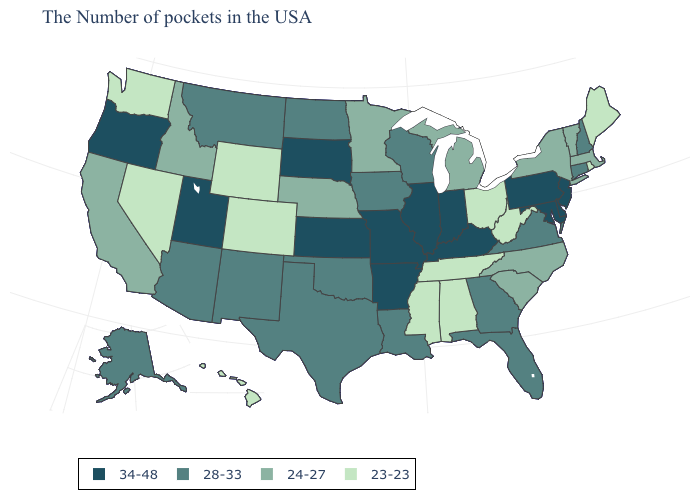What is the value of New Mexico?
Short answer required. 28-33. What is the value of Vermont?
Answer briefly. 24-27. Does South Dakota have the highest value in the USA?
Short answer required. Yes. Name the states that have a value in the range 34-48?
Concise answer only. New Jersey, Delaware, Maryland, Pennsylvania, Kentucky, Indiana, Illinois, Missouri, Arkansas, Kansas, South Dakota, Utah, Oregon. What is the value of New Hampshire?
Keep it brief. 28-33. What is the value of Ohio?
Give a very brief answer. 23-23. Among the states that border Iowa , which have the highest value?
Answer briefly. Illinois, Missouri, South Dakota. What is the value of Wyoming?
Concise answer only. 23-23. Name the states that have a value in the range 28-33?
Give a very brief answer. New Hampshire, Connecticut, Virginia, Florida, Georgia, Wisconsin, Louisiana, Iowa, Oklahoma, Texas, North Dakota, New Mexico, Montana, Arizona, Alaska. How many symbols are there in the legend?
Concise answer only. 4. What is the value of South Carolina?
Concise answer only. 24-27. Among the states that border Alabama , which have the lowest value?
Quick response, please. Tennessee, Mississippi. Which states have the highest value in the USA?
Answer briefly. New Jersey, Delaware, Maryland, Pennsylvania, Kentucky, Indiana, Illinois, Missouri, Arkansas, Kansas, South Dakota, Utah, Oregon. What is the value of Colorado?
Short answer required. 23-23. Name the states that have a value in the range 23-23?
Answer briefly. Maine, Rhode Island, West Virginia, Ohio, Alabama, Tennessee, Mississippi, Wyoming, Colorado, Nevada, Washington, Hawaii. 